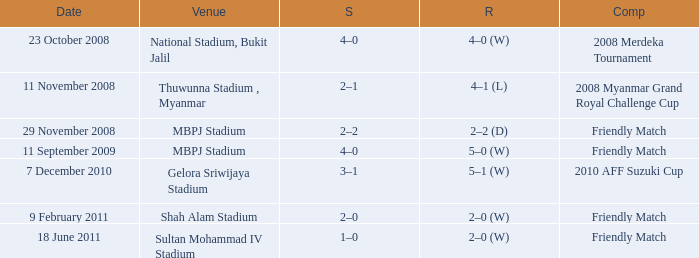What Competition in Shah Alam Stadium have a Result of 2–0 (w)? Friendly Match. 